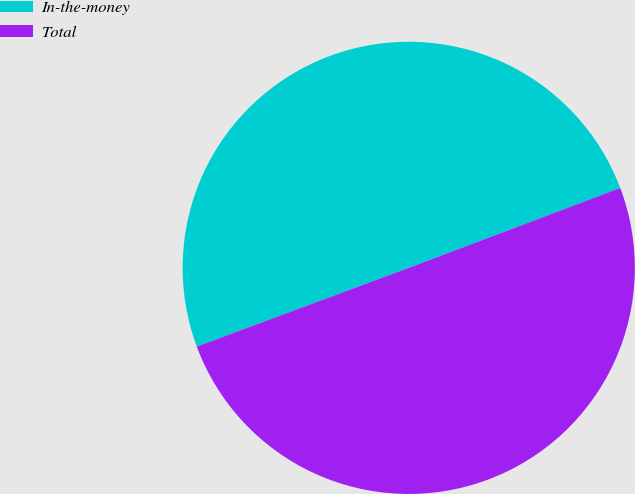<chart> <loc_0><loc_0><loc_500><loc_500><pie_chart><fcel>In-the-money<fcel>Total<nl><fcel>49.91%<fcel>50.09%<nl></chart> 